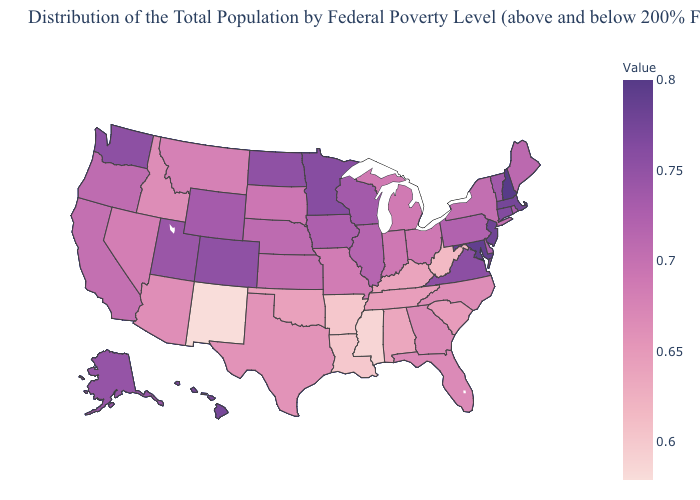Which states have the lowest value in the USA?
Concise answer only. New Mexico. Among the states that border Montana , which have the lowest value?
Keep it brief. Idaho. Does West Virginia have the highest value in the South?
Short answer required. No. Among the states that border Ohio , does West Virginia have the lowest value?
Concise answer only. Yes. Does Missouri have the lowest value in the MidWest?
Concise answer only. Yes. Which states have the highest value in the USA?
Be succinct. New Hampshire. Does Hawaii have a higher value than West Virginia?
Keep it brief. Yes. 